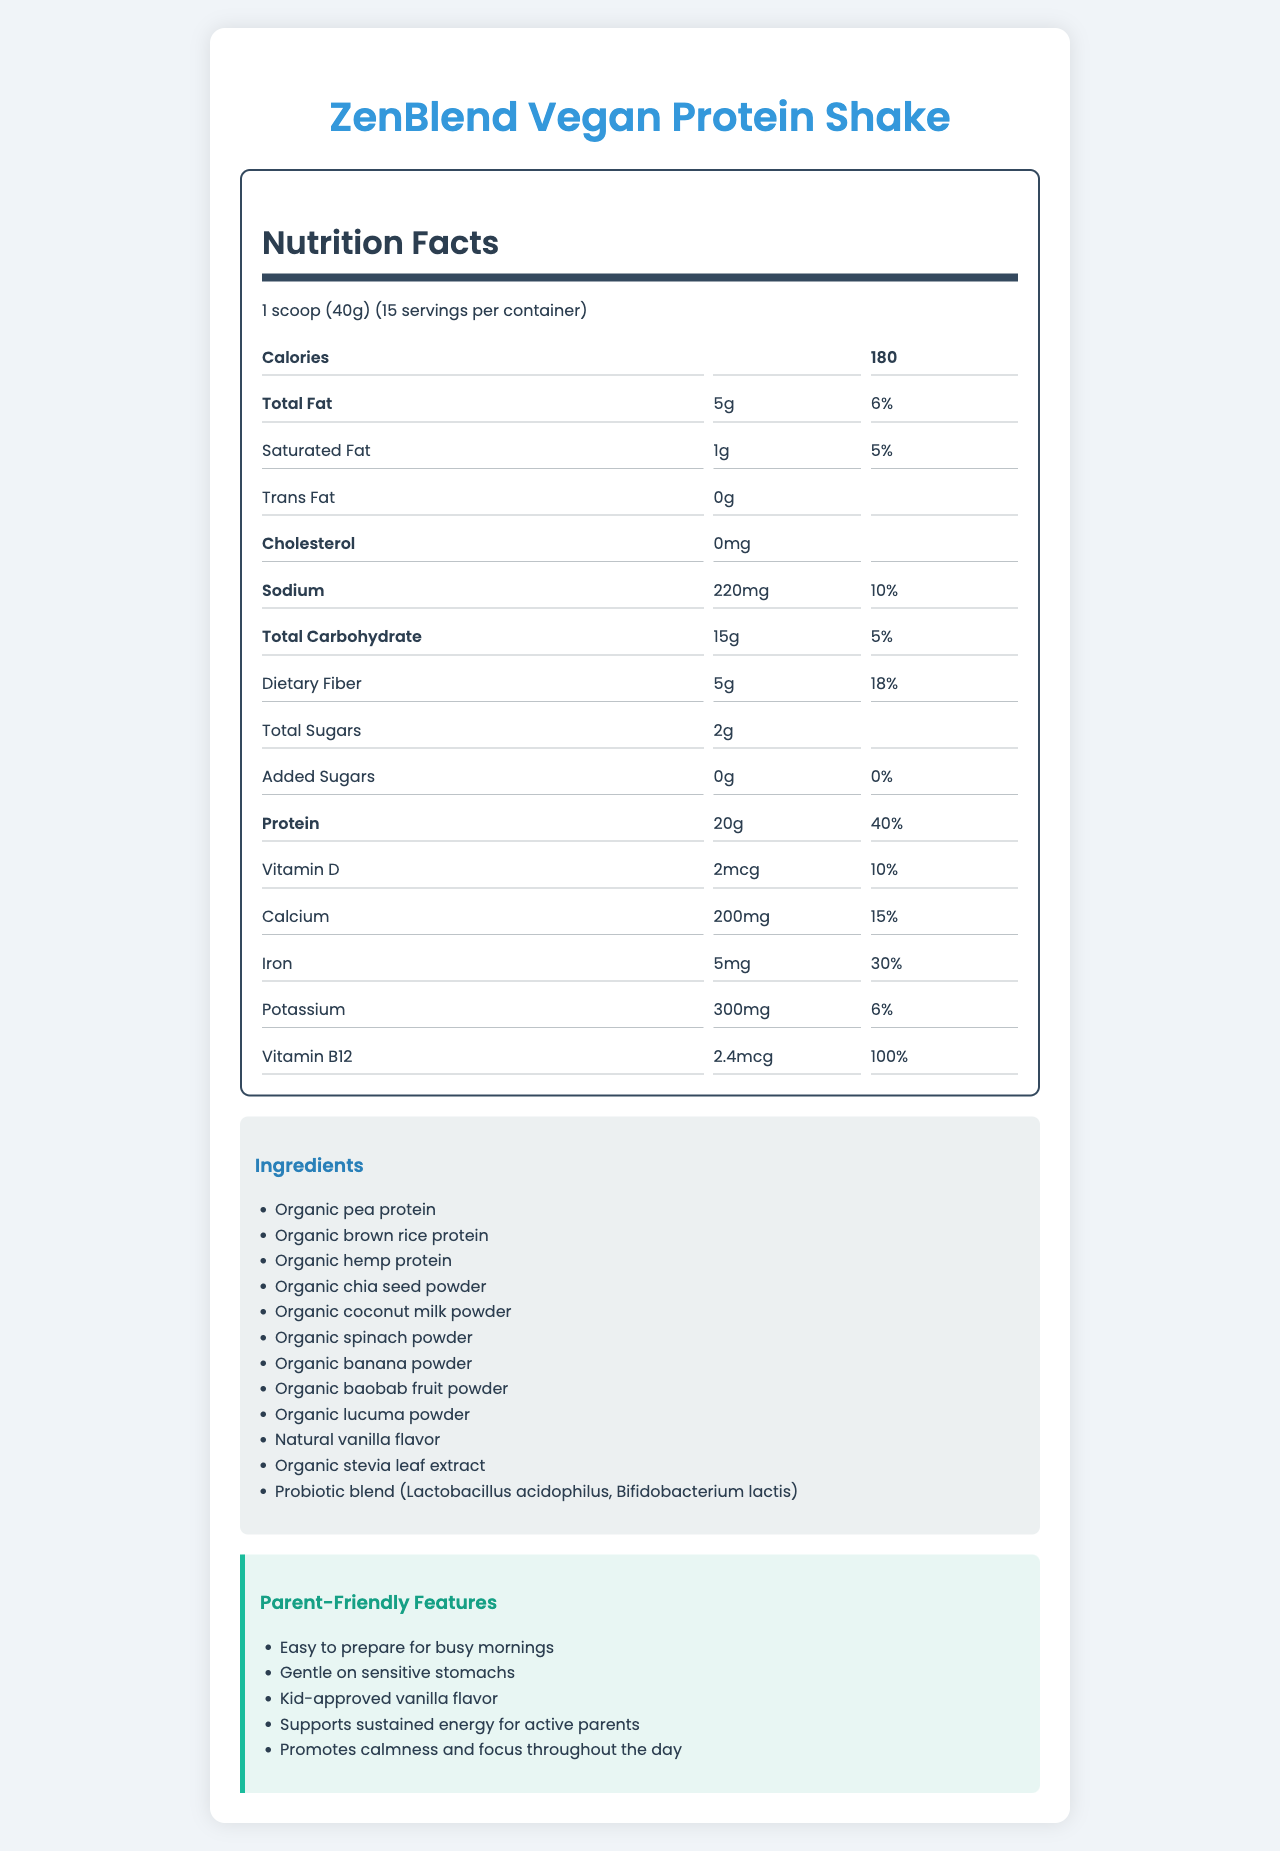what is the serving size for ZenBlend Vegan Protein Shake? The serving size is listed as "1 scoop (40g)" in the document.
Answer: 1 scoop (40g) how many servings are there per container? The document states that there are 15 servings per container.
Answer: 15 how many calories are in one serving of the shake? The document lists the calorie content as 180 per serving.
Answer: 180 how much protein does one serving contain? According to the document, one serving contains 20g of protein.
Answer: 20g what is the daily value percentage for dietary fiber? The daily value percentage for dietary fiber is listed as 18% in the document.
Answer: 18% which ingredient is not in the ZenBlend Vegan Protein Shake? A. Organic chia seed powder B. Organic baobab fruit powder C. Organic honey The ingredients list contains Organic chia seed powder and Organic baobab fruit powder, but does not mention Organic honey.
Answer: C what is the amount of iron per serving? A. 2mg B. 5mg C. 10mg The amount of iron per serving is listed as 5mg in the document.
Answer: B is the ZenBlend Vegan Protein Shake suitable for someone avoiding gluten? The product claims section states that the shake is gluten-free.
Answer: Yes describe the main features and nutritional information of ZenBlend Vegan Protein Shake. The document outlines the product name, serving size, number of servings, nutritional content, ingredients, allergen information, preparation instructions, and additional features focusing on its organic and digestively supportive aspects.
Answer: ZenBlend Vegan Protein Shake is a plant-based meal replacement shake with 15 servings per container and a serving size of 1 scoop (40g). Each serving contains 180 calories, 5g total fat, 15g total carbohydrates, 5g dietary fiber, 20g protein, along with various vitamins and minerals. The product is Non-GMO, gluten-free, dairy-free, soy-free, and contains no artificial flavors, colors, or preservatives. It also includes a blend of organic ingredients and probiotics for digestive support. does the product contain any tree nuts? The allergen info states that the product is manufactured in a facility that processes tree nuts, but it does not explicitly mention that the product itself contains tree nuts.
Answer: Not enough information 